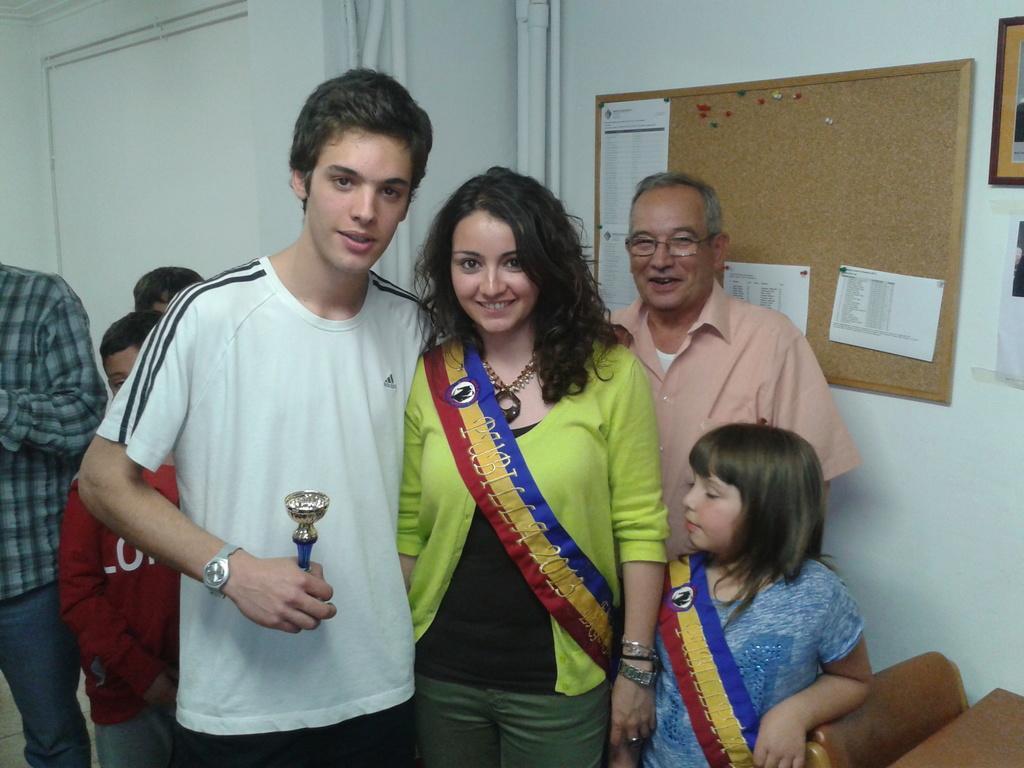Please provide a concise description of this image. In this image, we can see a boy holding prize and a lady wearing sash and smiling, we can see a girl wearing sash. In the background, we can see some kids and persons and there is a board with papers and we can see frame placed on the wall. 